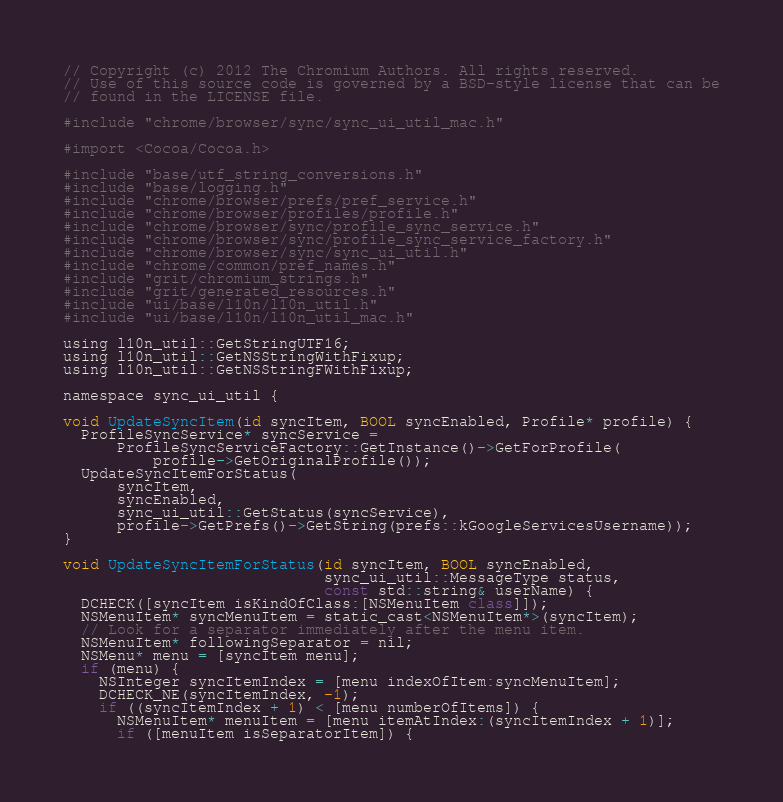Convert code to text. <code><loc_0><loc_0><loc_500><loc_500><_ObjectiveC_>// Copyright (c) 2012 The Chromium Authors. All rights reserved.
// Use of this source code is governed by a BSD-style license that can be
// found in the LICENSE file.

#include "chrome/browser/sync/sync_ui_util_mac.h"

#import <Cocoa/Cocoa.h>

#include "base/utf_string_conversions.h"
#include "base/logging.h"
#include "chrome/browser/prefs/pref_service.h"
#include "chrome/browser/profiles/profile.h"
#include "chrome/browser/sync/profile_sync_service.h"
#include "chrome/browser/sync/profile_sync_service_factory.h"
#include "chrome/browser/sync/sync_ui_util.h"
#include "chrome/common/pref_names.h"
#include "grit/chromium_strings.h"
#include "grit/generated_resources.h"
#include "ui/base/l10n/l10n_util.h"
#include "ui/base/l10n/l10n_util_mac.h"

using l10n_util::GetStringUTF16;
using l10n_util::GetNSStringWithFixup;
using l10n_util::GetNSStringFWithFixup;

namespace sync_ui_util {

void UpdateSyncItem(id syncItem, BOOL syncEnabled, Profile* profile) {
  ProfileSyncService* syncService =
      ProfileSyncServiceFactory::GetInstance()->GetForProfile(
          profile->GetOriginalProfile());
  UpdateSyncItemForStatus(
      syncItem,
      syncEnabled,
      sync_ui_util::GetStatus(syncService),
      profile->GetPrefs()->GetString(prefs::kGoogleServicesUsername));
}

void UpdateSyncItemForStatus(id syncItem, BOOL syncEnabled,
                             sync_ui_util::MessageType status,
                             const std::string& userName) {
  DCHECK([syncItem isKindOfClass:[NSMenuItem class]]);
  NSMenuItem* syncMenuItem = static_cast<NSMenuItem*>(syncItem);
  // Look for a separator immediately after the menu item.
  NSMenuItem* followingSeparator = nil;
  NSMenu* menu = [syncItem menu];
  if (menu) {
    NSInteger syncItemIndex = [menu indexOfItem:syncMenuItem];
    DCHECK_NE(syncItemIndex, -1);
    if ((syncItemIndex + 1) < [menu numberOfItems]) {
      NSMenuItem* menuItem = [menu itemAtIndex:(syncItemIndex + 1)];
      if ([menuItem isSeparatorItem]) {</code> 